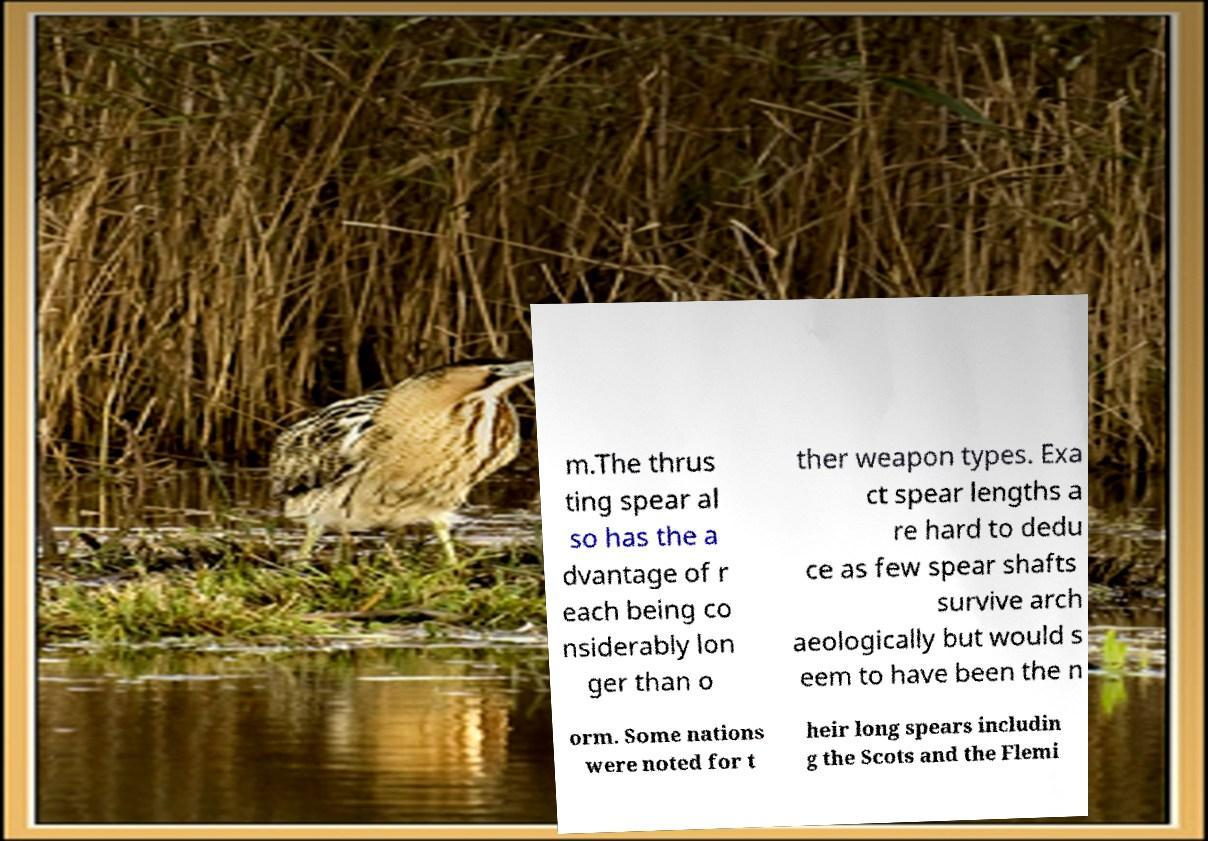What messages or text are displayed in this image? I need them in a readable, typed format. m.The thrus ting spear al so has the a dvantage of r each being co nsiderably lon ger than o ther weapon types. Exa ct spear lengths a re hard to dedu ce as few spear shafts survive arch aeologically but would s eem to have been the n orm. Some nations were noted for t heir long spears includin g the Scots and the Flemi 